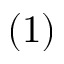<formula> <loc_0><loc_0><loc_500><loc_500>\left ( 1 \right )</formula> 